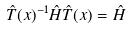Convert formula to latex. <formula><loc_0><loc_0><loc_500><loc_500>\hat { T } ( x ) ^ { - 1 } \hat { H } \hat { T } ( x ) = \hat { H }</formula> 